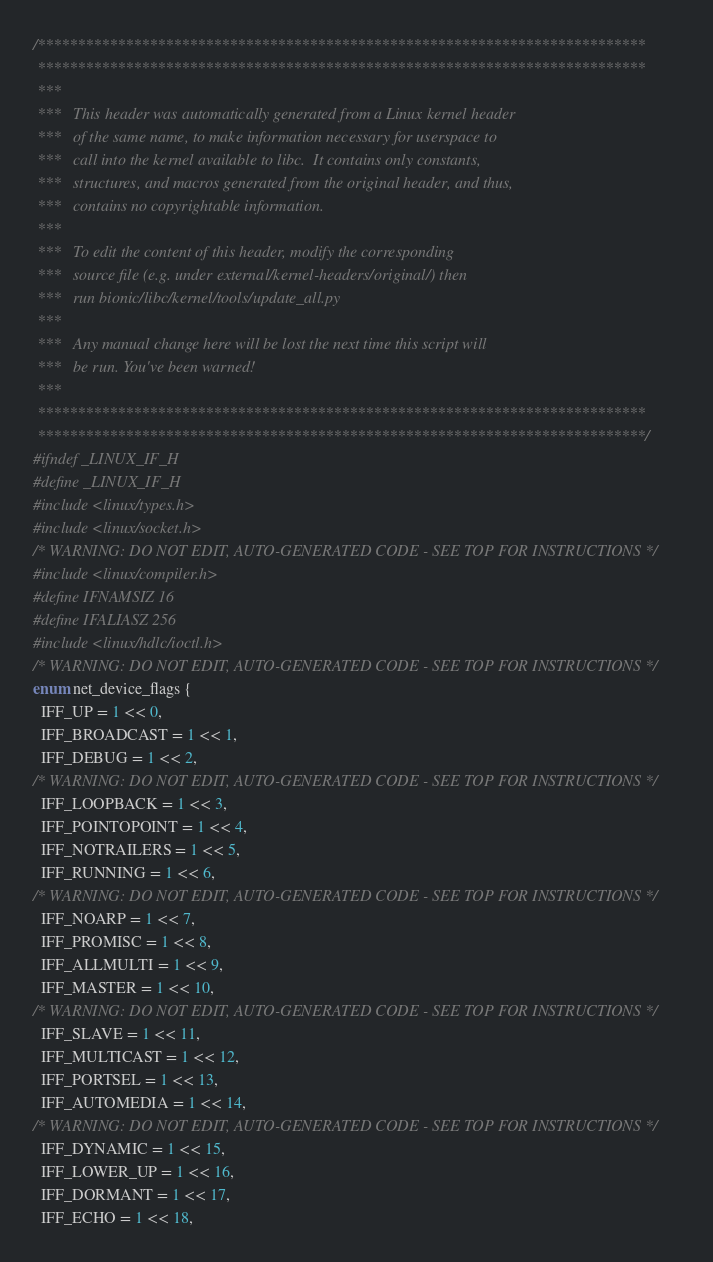Convert code to text. <code><loc_0><loc_0><loc_500><loc_500><_C_>/****************************************************************************
 ****************************************************************************
 ***
 ***   This header was automatically generated from a Linux kernel header
 ***   of the same name, to make information necessary for userspace to
 ***   call into the kernel available to libc.  It contains only constants,
 ***   structures, and macros generated from the original header, and thus,
 ***   contains no copyrightable information.
 ***
 ***   To edit the content of this header, modify the corresponding
 ***   source file (e.g. under external/kernel-headers/original/) then
 ***   run bionic/libc/kernel/tools/update_all.py
 ***
 ***   Any manual change here will be lost the next time this script will
 ***   be run. You've been warned!
 ***
 ****************************************************************************
 ****************************************************************************/
#ifndef _LINUX_IF_H
#define _LINUX_IF_H
#include <linux/types.h>
#include <linux/socket.h>
/* WARNING: DO NOT EDIT, AUTO-GENERATED CODE - SEE TOP FOR INSTRUCTIONS */
#include <linux/compiler.h>
#define IFNAMSIZ 16
#define IFALIASZ 256
#include <linux/hdlc/ioctl.h>
/* WARNING: DO NOT EDIT, AUTO-GENERATED CODE - SEE TOP FOR INSTRUCTIONS */
enum net_device_flags {
  IFF_UP = 1 << 0,
  IFF_BROADCAST = 1 << 1,
  IFF_DEBUG = 1 << 2,
/* WARNING: DO NOT EDIT, AUTO-GENERATED CODE - SEE TOP FOR INSTRUCTIONS */
  IFF_LOOPBACK = 1 << 3,
  IFF_POINTOPOINT = 1 << 4,
  IFF_NOTRAILERS = 1 << 5,
  IFF_RUNNING = 1 << 6,
/* WARNING: DO NOT EDIT, AUTO-GENERATED CODE - SEE TOP FOR INSTRUCTIONS */
  IFF_NOARP = 1 << 7,
  IFF_PROMISC = 1 << 8,
  IFF_ALLMULTI = 1 << 9,
  IFF_MASTER = 1 << 10,
/* WARNING: DO NOT EDIT, AUTO-GENERATED CODE - SEE TOP FOR INSTRUCTIONS */
  IFF_SLAVE = 1 << 11,
  IFF_MULTICAST = 1 << 12,
  IFF_PORTSEL = 1 << 13,
  IFF_AUTOMEDIA = 1 << 14,
/* WARNING: DO NOT EDIT, AUTO-GENERATED CODE - SEE TOP FOR INSTRUCTIONS */
  IFF_DYNAMIC = 1 << 15,
  IFF_LOWER_UP = 1 << 16,
  IFF_DORMANT = 1 << 17,
  IFF_ECHO = 1 << 18,</code> 